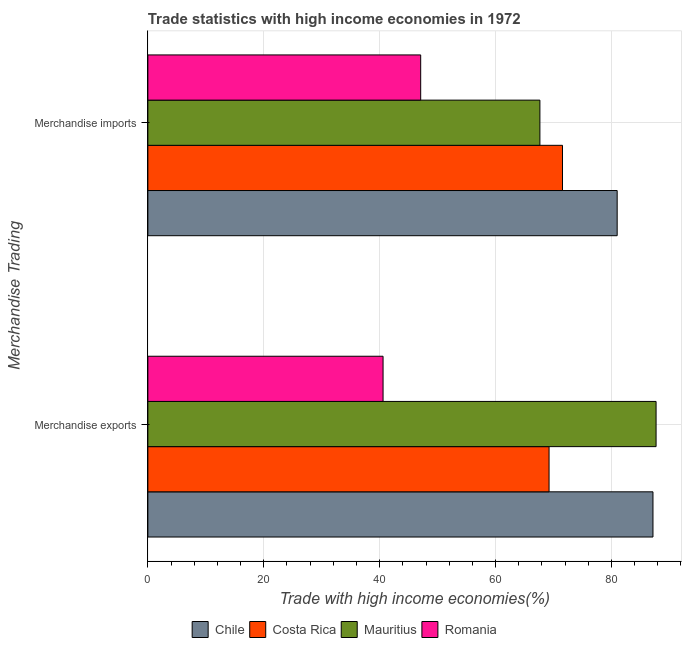How many groups of bars are there?
Make the answer very short. 2. Are the number of bars per tick equal to the number of legend labels?
Offer a terse response. Yes. Are the number of bars on each tick of the Y-axis equal?
Offer a very short reply. Yes. How many bars are there on the 2nd tick from the bottom?
Your answer should be very brief. 4. What is the label of the 2nd group of bars from the top?
Give a very brief answer. Merchandise exports. What is the merchandise imports in Romania?
Offer a very short reply. 47.08. Across all countries, what is the maximum merchandise exports?
Keep it short and to the point. 87.71. Across all countries, what is the minimum merchandise imports?
Your response must be concise. 47.08. In which country was the merchandise exports maximum?
Offer a terse response. Mauritius. In which country was the merchandise exports minimum?
Offer a terse response. Romania. What is the total merchandise imports in the graph?
Your response must be concise. 267.3. What is the difference between the merchandise imports in Costa Rica and that in Chile?
Offer a terse response. -9.44. What is the difference between the merchandise exports in Costa Rica and the merchandise imports in Romania?
Ensure brevity in your answer.  22.16. What is the average merchandise imports per country?
Make the answer very short. 66.82. What is the difference between the merchandise imports and merchandise exports in Chile?
Ensure brevity in your answer.  -6.18. What is the ratio of the merchandise exports in Chile to that in Mauritius?
Keep it short and to the point. 0.99. Is the merchandise exports in Costa Rica less than that in Romania?
Offer a very short reply. No. In how many countries, is the merchandise exports greater than the average merchandise exports taken over all countries?
Offer a terse response. 2. What does the 2nd bar from the top in Merchandise exports represents?
Provide a short and direct response. Mauritius. What does the 3rd bar from the bottom in Merchandise exports represents?
Give a very brief answer. Mauritius. How many countries are there in the graph?
Your answer should be very brief. 4. What is the difference between two consecutive major ticks on the X-axis?
Provide a succinct answer. 20. Does the graph contain any zero values?
Your response must be concise. No. How many legend labels are there?
Provide a short and direct response. 4. What is the title of the graph?
Ensure brevity in your answer.  Trade statistics with high income economies in 1972. Does "Macedonia" appear as one of the legend labels in the graph?
Make the answer very short. No. What is the label or title of the X-axis?
Offer a terse response. Trade with high income economies(%). What is the label or title of the Y-axis?
Offer a very short reply. Merchandise Trading. What is the Trade with high income economies(%) of Chile in Merchandise exports?
Offer a terse response. 87.17. What is the Trade with high income economies(%) of Costa Rica in Merchandise exports?
Provide a short and direct response. 69.24. What is the Trade with high income economies(%) in Mauritius in Merchandise exports?
Your response must be concise. 87.71. What is the Trade with high income economies(%) in Romania in Merchandise exports?
Your answer should be very brief. 40.59. What is the Trade with high income economies(%) of Chile in Merchandise imports?
Ensure brevity in your answer.  81. What is the Trade with high income economies(%) of Costa Rica in Merchandise imports?
Offer a terse response. 71.56. What is the Trade with high income economies(%) in Mauritius in Merchandise imports?
Your answer should be compact. 67.66. What is the Trade with high income economies(%) of Romania in Merchandise imports?
Offer a very short reply. 47.08. Across all Merchandise Trading, what is the maximum Trade with high income economies(%) of Chile?
Offer a terse response. 87.17. Across all Merchandise Trading, what is the maximum Trade with high income economies(%) in Costa Rica?
Offer a terse response. 71.56. Across all Merchandise Trading, what is the maximum Trade with high income economies(%) of Mauritius?
Give a very brief answer. 87.71. Across all Merchandise Trading, what is the maximum Trade with high income economies(%) of Romania?
Offer a terse response. 47.08. Across all Merchandise Trading, what is the minimum Trade with high income economies(%) in Chile?
Make the answer very short. 81. Across all Merchandise Trading, what is the minimum Trade with high income economies(%) of Costa Rica?
Offer a very short reply. 69.24. Across all Merchandise Trading, what is the minimum Trade with high income economies(%) in Mauritius?
Your answer should be compact. 67.66. Across all Merchandise Trading, what is the minimum Trade with high income economies(%) in Romania?
Keep it short and to the point. 40.59. What is the total Trade with high income economies(%) of Chile in the graph?
Offer a terse response. 168.17. What is the total Trade with high income economies(%) in Costa Rica in the graph?
Provide a short and direct response. 140.8. What is the total Trade with high income economies(%) in Mauritius in the graph?
Keep it short and to the point. 155.37. What is the total Trade with high income economies(%) of Romania in the graph?
Your answer should be compact. 87.67. What is the difference between the Trade with high income economies(%) in Chile in Merchandise exports and that in Merchandise imports?
Provide a succinct answer. 6.18. What is the difference between the Trade with high income economies(%) of Costa Rica in Merchandise exports and that in Merchandise imports?
Make the answer very short. -2.32. What is the difference between the Trade with high income economies(%) of Mauritius in Merchandise exports and that in Merchandise imports?
Give a very brief answer. 20.05. What is the difference between the Trade with high income economies(%) in Romania in Merchandise exports and that in Merchandise imports?
Your answer should be very brief. -6.49. What is the difference between the Trade with high income economies(%) in Chile in Merchandise exports and the Trade with high income economies(%) in Costa Rica in Merchandise imports?
Your response must be concise. 15.61. What is the difference between the Trade with high income economies(%) in Chile in Merchandise exports and the Trade with high income economies(%) in Mauritius in Merchandise imports?
Your response must be concise. 19.51. What is the difference between the Trade with high income economies(%) in Chile in Merchandise exports and the Trade with high income economies(%) in Romania in Merchandise imports?
Provide a short and direct response. 40.09. What is the difference between the Trade with high income economies(%) in Costa Rica in Merchandise exports and the Trade with high income economies(%) in Mauritius in Merchandise imports?
Offer a very short reply. 1.58. What is the difference between the Trade with high income economies(%) of Costa Rica in Merchandise exports and the Trade with high income economies(%) of Romania in Merchandise imports?
Your answer should be compact. 22.16. What is the difference between the Trade with high income economies(%) in Mauritius in Merchandise exports and the Trade with high income economies(%) in Romania in Merchandise imports?
Your response must be concise. 40.63. What is the average Trade with high income economies(%) of Chile per Merchandise Trading?
Offer a very short reply. 84.08. What is the average Trade with high income economies(%) of Costa Rica per Merchandise Trading?
Offer a terse response. 70.4. What is the average Trade with high income economies(%) of Mauritius per Merchandise Trading?
Your answer should be compact. 77.68. What is the average Trade with high income economies(%) of Romania per Merchandise Trading?
Make the answer very short. 43.84. What is the difference between the Trade with high income economies(%) of Chile and Trade with high income economies(%) of Costa Rica in Merchandise exports?
Offer a very short reply. 17.93. What is the difference between the Trade with high income economies(%) in Chile and Trade with high income economies(%) in Mauritius in Merchandise exports?
Provide a short and direct response. -0.54. What is the difference between the Trade with high income economies(%) of Chile and Trade with high income economies(%) of Romania in Merchandise exports?
Offer a very short reply. 46.58. What is the difference between the Trade with high income economies(%) of Costa Rica and Trade with high income economies(%) of Mauritius in Merchandise exports?
Offer a terse response. -18.47. What is the difference between the Trade with high income economies(%) in Costa Rica and Trade with high income economies(%) in Romania in Merchandise exports?
Provide a short and direct response. 28.65. What is the difference between the Trade with high income economies(%) of Mauritius and Trade with high income economies(%) of Romania in Merchandise exports?
Your answer should be very brief. 47.12. What is the difference between the Trade with high income economies(%) of Chile and Trade with high income economies(%) of Costa Rica in Merchandise imports?
Offer a very short reply. 9.44. What is the difference between the Trade with high income economies(%) of Chile and Trade with high income economies(%) of Mauritius in Merchandise imports?
Make the answer very short. 13.34. What is the difference between the Trade with high income economies(%) in Chile and Trade with high income economies(%) in Romania in Merchandise imports?
Offer a terse response. 33.91. What is the difference between the Trade with high income economies(%) in Costa Rica and Trade with high income economies(%) in Mauritius in Merchandise imports?
Give a very brief answer. 3.9. What is the difference between the Trade with high income economies(%) of Costa Rica and Trade with high income economies(%) of Romania in Merchandise imports?
Keep it short and to the point. 24.48. What is the difference between the Trade with high income economies(%) of Mauritius and Trade with high income economies(%) of Romania in Merchandise imports?
Your response must be concise. 20.58. What is the ratio of the Trade with high income economies(%) of Chile in Merchandise exports to that in Merchandise imports?
Your answer should be compact. 1.08. What is the ratio of the Trade with high income economies(%) of Costa Rica in Merchandise exports to that in Merchandise imports?
Offer a very short reply. 0.97. What is the ratio of the Trade with high income economies(%) in Mauritius in Merchandise exports to that in Merchandise imports?
Keep it short and to the point. 1.3. What is the ratio of the Trade with high income economies(%) in Romania in Merchandise exports to that in Merchandise imports?
Ensure brevity in your answer.  0.86. What is the difference between the highest and the second highest Trade with high income economies(%) in Chile?
Provide a short and direct response. 6.18. What is the difference between the highest and the second highest Trade with high income economies(%) in Costa Rica?
Your answer should be compact. 2.32. What is the difference between the highest and the second highest Trade with high income economies(%) of Mauritius?
Give a very brief answer. 20.05. What is the difference between the highest and the second highest Trade with high income economies(%) in Romania?
Ensure brevity in your answer.  6.49. What is the difference between the highest and the lowest Trade with high income economies(%) of Chile?
Offer a terse response. 6.18. What is the difference between the highest and the lowest Trade with high income economies(%) of Costa Rica?
Offer a terse response. 2.32. What is the difference between the highest and the lowest Trade with high income economies(%) of Mauritius?
Ensure brevity in your answer.  20.05. What is the difference between the highest and the lowest Trade with high income economies(%) of Romania?
Ensure brevity in your answer.  6.49. 